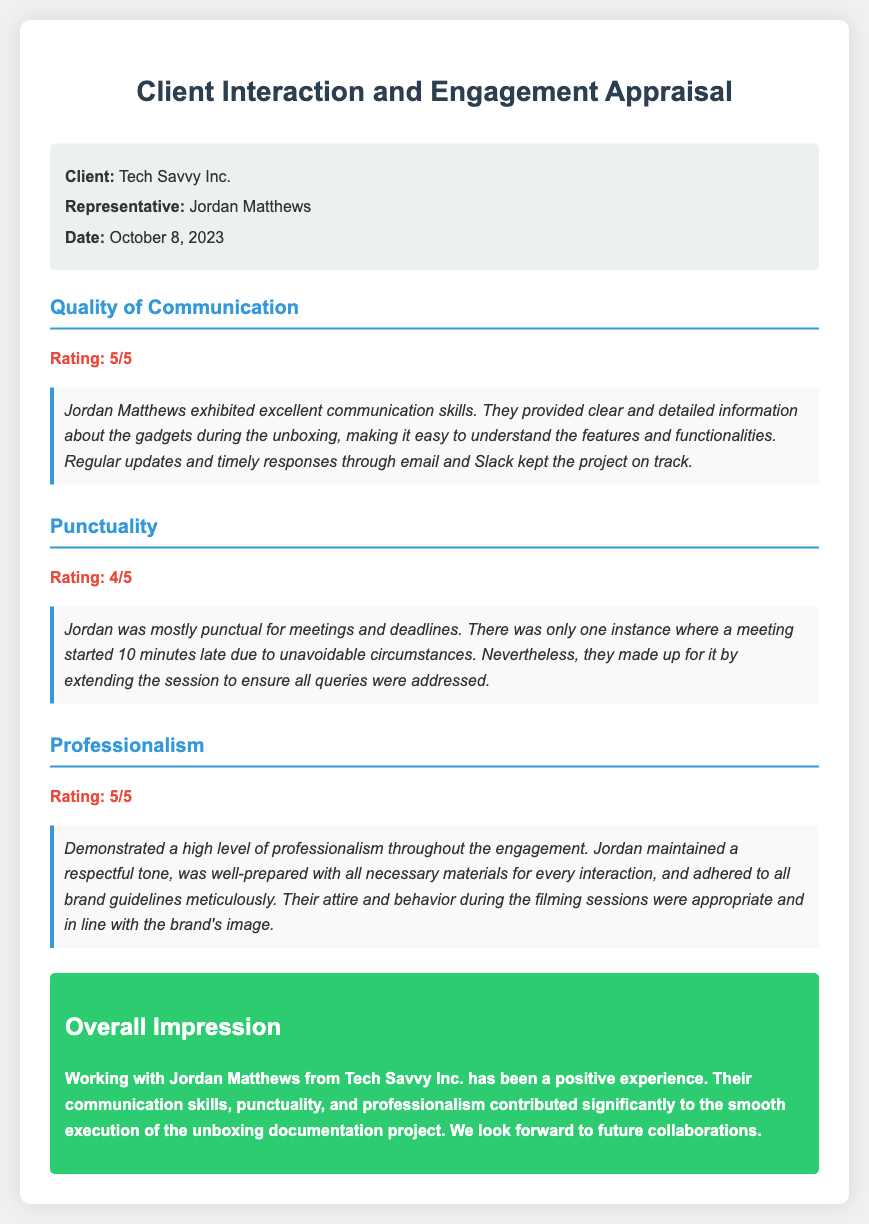what is the name of the client? The name of the client is provided in the client info section of the document.
Answer: Tech Savvy Inc who is the representative mentioned in the document? The representative's name is listed in the client info section.
Answer: Jordan Matthews on what date was the appraisal conducted? The date of the appraisal is specified in the client info section.
Answer: October 8, 2023 what is the rating for Quality of Communication? The rating is shown in the Quality of Communication section of the document.
Answer: 5/5 how many minutes late was the meeting that Jordan attended? The document indicates the delay in punctuality under the Punctuality section.
Answer: 10 minutes what was the overall impression of working with Jordan Matthews? The overall impression is summarized in the Overall Impression section of the document.
Answer: Positive experience how is Jordan described in terms of professionalism? The description of professionalism is detailed in the Professionalism section.
Answer: High level what issue occurred with punctuality? The punctuality section describes an issue that happened during one meeting.
Answer: One meeting started late did Jordan provide timely updates? A specific comment about updates is made in the Quality of Communication section.
Answer: Yes 